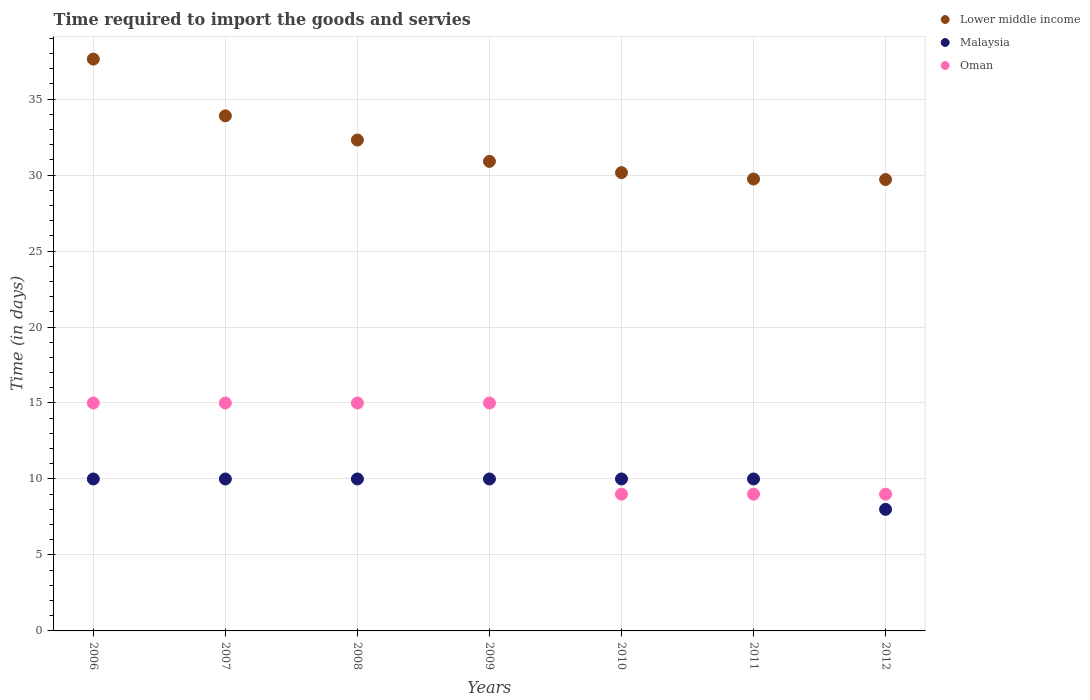How many different coloured dotlines are there?
Ensure brevity in your answer.  3. Is the number of dotlines equal to the number of legend labels?
Your answer should be very brief. Yes. What is the number of days required to import the goods and services in Malaysia in 2006?
Your answer should be very brief. 10. Across all years, what is the maximum number of days required to import the goods and services in Malaysia?
Make the answer very short. 10. Across all years, what is the minimum number of days required to import the goods and services in Oman?
Offer a terse response. 9. In which year was the number of days required to import the goods and services in Lower middle income maximum?
Your answer should be very brief. 2006. What is the total number of days required to import the goods and services in Malaysia in the graph?
Your response must be concise. 68. What is the difference between the number of days required to import the goods and services in Oman in 2009 and the number of days required to import the goods and services in Lower middle income in 2008?
Offer a terse response. -17.31. What is the average number of days required to import the goods and services in Oman per year?
Your response must be concise. 12.43. In the year 2006, what is the difference between the number of days required to import the goods and services in Lower middle income and number of days required to import the goods and services in Oman?
Make the answer very short. 22.63. In how many years, is the number of days required to import the goods and services in Oman greater than 9 days?
Keep it short and to the point. 4. What is the ratio of the number of days required to import the goods and services in Oman in 2006 to that in 2011?
Provide a short and direct response. 1.67. Is the number of days required to import the goods and services in Malaysia in 2008 less than that in 2010?
Give a very brief answer. No. What is the difference between the highest and the lowest number of days required to import the goods and services in Malaysia?
Your answer should be very brief. 2. Is the sum of the number of days required to import the goods and services in Lower middle income in 2011 and 2012 greater than the maximum number of days required to import the goods and services in Oman across all years?
Your answer should be compact. Yes. Is it the case that in every year, the sum of the number of days required to import the goods and services in Lower middle income and number of days required to import the goods and services in Oman  is greater than the number of days required to import the goods and services in Malaysia?
Your response must be concise. Yes. Does the number of days required to import the goods and services in Malaysia monotonically increase over the years?
Offer a very short reply. No. How many dotlines are there?
Your answer should be compact. 3. Are the values on the major ticks of Y-axis written in scientific E-notation?
Provide a succinct answer. No. Does the graph contain grids?
Provide a succinct answer. Yes. Where does the legend appear in the graph?
Your answer should be compact. Top right. How many legend labels are there?
Offer a very short reply. 3. What is the title of the graph?
Offer a terse response. Time required to import the goods and servies. Does "Benin" appear as one of the legend labels in the graph?
Give a very brief answer. No. What is the label or title of the X-axis?
Offer a terse response. Years. What is the label or title of the Y-axis?
Your answer should be very brief. Time (in days). What is the Time (in days) in Lower middle income in 2006?
Make the answer very short. 37.63. What is the Time (in days) of Oman in 2006?
Offer a terse response. 15. What is the Time (in days) in Lower middle income in 2007?
Ensure brevity in your answer.  33.9. What is the Time (in days) in Malaysia in 2007?
Make the answer very short. 10. What is the Time (in days) in Lower middle income in 2008?
Make the answer very short. 32.31. What is the Time (in days) of Lower middle income in 2009?
Give a very brief answer. 30.9. What is the Time (in days) of Oman in 2009?
Your answer should be very brief. 15. What is the Time (in days) of Lower middle income in 2010?
Give a very brief answer. 30.16. What is the Time (in days) in Malaysia in 2010?
Your answer should be very brief. 10. What is the Time (in days) in Oman in 2010?
Provide a short and direct response. 9. What is the Time (in days) in Lower middle income in 2011?
Make the answer very short. 29.74. What is the Time (in days) in Malaysia in 2011?
Offer a terse response. 10. What is the Time (in days) of Lower middle income in 2012?
Your response must be concise. 29.71. What is the Time (in days) of Malaysia in 2012?
Make the answer very short. 8. What is the Time (in days) in Oman in 2012?
Provide a short and direct response. 9. Across all years, what is the maximum Time (in days) in Lower middle income?
Provide a short and direct response. 37.63. Across all years, what is the maximum Time (in days) in Malaysia?
Your response must be concise. 10. Across all years, what is the maximum Time (in days) of Oman?
Your answer should be compact. 15. Across all years, what is the minimum Time (in days) of Lower middle income?
Offer a terse response. 29.71. Across all years, what is the minimum Time (in days) in Oman?
Keep it short and to the point. 9. What is the total Time (in days) in Lower middle income in the graph?
Give a very brief answer. 224.34. What is the total Time (in days) in Oman in the graph?
Provide a short and direct response. 87. What is the difference between the Time (in days) of Lower middle income in 2006 and that in 2007?
Keep it short and to the point. 3.73. What is the difference between the Time (in days) of Lower middle income in 2006 and that in 2008?
Offer a terse response. 5.33. What is the difference between the Time (in days) of Oman in 2006 and that in 2008?
Ensure brevity in your answer.  0. What is the difference between the Time (in days) of Lower middle income in 2006 and that in 2009?
Your answer should be compact. 6.73. What is the difference between the Time (in days) of Malaysia in 2006 and that in 2009?
Your answer should be compact. 0. What is the difference between the Time (in days) of Lower middle income in 2006 and that in 2010?
Provide a succinct answer. 7.47. What is the difference between the Time (in days) of Malaysia in 2006 and that in 2010?
Your answer should be very brief. 0. What is the difference between the Time (in days) in Lower middle income in 2006 and that in 2011?
Provide a succinct answer. 7.89. What is the difference between the Time (in days) in Malaysia in 2006 and that in 2011?
Ensure brevity in your answer.  0. What is the difference between the Time (in days) of Oman in 2006 and that in 2011?
Your answer should be very brief. 6. What is the difference between the Time (in days) in Lower middle income in 2006 and that in 2012?
Provide a succinct answer. 7.93. What is the difference between the Time (in days) of Oman in 2006 and that in 2012?
Make the answer very short. 6. What is the difference between the Time (in days) in Lower middle income in 2007 and that in 2008?
Provide a short and direct response. 1.59. What is the difference between the Time (in days) of Malaysia in 2007 and that in 2008?
Offer a very short reply. 0. What is the difference between the Time (in days) of Oman in 2007 and that in 2008?
Your response must be concise. 0. What is the difference between the Time (in days) of Lower middle income in 2007 and that in 2009?
Your answer should be very brief. 3. What is the difference between the Time (in days) of Malaysia in 2007 and that in 2009?
Offer a very short reply. 0. What is the difference between the Time (in days) of Oman in 2007 and that in 2009?
Your response must be concise. 0. What is the difference between the Time (in days) in Lower middle income in 2007 and that in 2010?
Provide a succinct answer. 3.74. What is the difference between the Time (in days) in Malaysia in 2007 and that in 2010?
Provide a succinct answer. 0. What is the difference between the Time (in days) in Lower middle income in 2007 and that in 2011?
Provide a short and direct response. 4.16. What is the difference between the Time (in days) of Oman in 2007 and that in 2011?
Keep it short and to the point. 6. What is the difference between the Time (in days) in Lower middle income in 2007 and that in 2012?
Your answer should be very brief. 4.19. What is the difference between the Time (in days) in Oman in 2007 and that in 2012?
Your answer should be very brief. 6. What is the difference between the Time (in days) of Lower middle income in 2008 and that in 2009?
Ensure brevity in your answer.  1.41. What is the difference between the Time (in days) in Malaysia in 2008 and that in 2009?
Keep it short and to the point. 0. What is the difference between the Time (in days) of Lower middle income in 2008 and that in 2010?
Your response must be concise. 2.15. What is the difference between the Time (in days) in Malaysia in 2008 and that in 2010?
Your answer should be very brief. 0. What is the difference between the Time (in days) of Lower middle income in 2008 and that in 2011?
Provide a short and direct response. 2.57. What is the difference between the Time (in days) in Lower middle income in 2008 and that in 2012?
Your response must be concise. 2.6. What is the difference between the Time (in days) of Malaysia in 2008 and that in 2012?
Your answer should be very brief. 2. What is the difference between the Time (in days) in Oman in 2008 and that in 2012?
Offer a very short reply. 6. What is the difference between the Time (in days) in Lower middle income in 2009 and that in 2010?
Make the answer very short. 0.74. What is the difference between the Time (in days) in Malaysia in 2009 and that in 2010?
Give a very brief answer. 0. What is the difference between the Time (in days) of Lower middle income in 2009 and that in 2011?
Your answer should be compact. 1.16. What is the difference between the Time (in days) in Malaysia in 2009 and that in 2011?
Offer a terse response. 0. What is the difference between the Time (in days) in Lower middle income in 2009 and that in 2012?
Give a very brief answer. 1.19. What is the difference between the Time (in days) in Oman in 2009 and that in 2012?
Offer a very short reply. 6. What is the difference between the Time (in days) of Lower middle income in 2010 and that in 2011?
Your answer should be very brief. 0.42. What is the difference between the Time (in days) in Oman in 2010 and that in 2011?
Your answer should be very brief. 0. What is the difference between the Time (in days) in Lower middle income in 2010 and that in 2012?
Your response must be concise. 0.45. What is the difference between the Time (in days) of Malaysia in 2010 and that in 2012?
Provide a succinct answer. 2. What is the difference between the Time (in days) in Lower middle income in 2011 and that in 2012?
Ensure brevity in your answer.  0.03. What is the difference between the Time (in days) of Malaysia in 2011 and that in 2012?
Your response must be concise. 2. What is the difference between the Time (in days) in Oman in 2011 and that in 2012?
Your response must be concise. 0. What is the difference between the Time (in days) of Lower middle income in 2006 and the Time (in days) of Malaysia in 2007?
Make the answer very short. 27.63. What is the difference between the Time (in days) in Lower middle income in 2006 and the Time (in days) in Oman in 2007?
Provide a succinct answer. 22.63. What is the difference between the Time (in days) in Malaysia in 2006 and the Time (in days) in Oman in 2007?
Your answer should be very brief. -5. What is the difference between the Time (in days) of Lower middle income in 2006 and the Time (in days) of Malaysia in 2008?
Provide a short and direct response. 27.63. What is the difference between the Time (in days) in Lower middle income in 2006 and the Time (in days) in Oman in 2008?
Provide a succinct answer. 22.63. What is the difference between the Time (in days) of Lower middle income in 2006 and the Time (in days) of Malaysia in 2009?
Offer a very short reply. 27.63. What is the difference between the Time (in days) in Lower middle income in 2006 and the Time (in days) in Oman in 2009?
Give a very brief answer. 22.63. What is the difference between the Time (in days) in Malaysia in 2006 and the Time (in days) in Oman in 2009?
Provide a short and direct response. -5. What is the difference between the Time (in days) of Lower middle income in 2006 and the Time (in days) of Malaysia in 2010?
Give a very brief answer. 27.63. What is the difference between the Time (in days) in Lower middle income in 2006 and the Time (in days) in Oman in 2010?
Your answer should be compact. 28.63. What is the difference between the Time (in days) of Lower middle income in 2006 and the Time (in days) of Malaysia in 2011?
Ensure brevity in your answer.  27.63. What is the difference between the Time (in days) of Lower middle income in 2006 and the Time (in days) of Oman in 2011?
Provide a short and direct response. 28.63. What is the difference between the Time (in days) in Lower middle income in 2006 and the Time (in days) in Malaysia in 2012?
Your answer should be very brief. 29.63. What is the difference between the Time (in days) in Lower middle income in 2006 and the Time (in days) in Oman in 2012?
Your response must be concise. 28.63. What is the difference between the Time (in days) of Lower middle income in 2007 and the Time (in days) of Malaysia in 2008?
Ensure brevity in your answer.  23.9. What is the difference between the Time (in days) of Lower middle income in 2007 and the Time (in days) of Oman in 2008?
Your response must be concise. 18.9. What is the difference between the Time (in days) in Malaysia in 2007 and the Time (in days) in Oman in 2008?
Your answer should be very brief. -5. What is the difference between the Time (in days) in Lower middle income in 2007 and the Time (in days) in Malaysia in 2009?
Keep it short and to the point. 23.9. What is the difference between the Time (in days) of Lower middle income in 2007 and the Time (in days) of Oman in 2009?
Your response must be concise. 18.9. What is the difference between the Time (in days) in Lower middle income in 2007 and the Time (in days) in Malaysia in 2010?
Provide a succinct answer. 23.9. What is the difference between the Time (in days) in Lower middle income in 2007 and the Time (in days) in Oman in 2010?
Make the answer very short. 24.9. What is the difference between the Time (in days) in Lower middle income in 2007 and the Time (in days) in Malaysia in 2011?
Provide a short and direct response. 23.9. What is the difference between the Time (in days) of Lower middle income in 2007 and the Time (in days) of Oman in 2011?
Your answer should be compact. 24.9. What is the difference between the Time (in days) of Lower middle income in 2007 and the Time (in days) of Malaysia in 2012?
Provide a short and direct response. 25.9. What is the difference between the Time (in days) in Lower middle income in 2007 and the Time (in days) in Oman in 2012?
Your answer should be compact. 24.9. What is the difference between the Time (in days) of Malaysia in 2007 and the Time (in days) of Oman in 2012?
Offer a very short reply. 1. What is the difference between the Time (in days) of Lower middle income in 2008 and the Time (in days) of Malaysia in 2009?
Your answer should be very brief. 22.31. What is the difference between the Time (in days) of Lower middle income in 2008 and the Time (in days) of Oman in 2009?
Provide a succinct answer. 17.31. What is the difference between the Time (in days) in Lower middle income in 2008 and the Time (in days) in Malaysia in 2010?
Your answer should be compact. 22.31. What is the difference between the Time (in days) of Lower middle income in 2008 and the Time (in days) of Oman in 2010?
Offer a very short reply. 23.31. What is the difference between the Time (in days) of Lower middle income in 2008 and the Time (in days) of Malaysia in 2011?
Give a very brief answer. 22.31. What is the difference between the Time (in days) in Lower middle income in 2008 and the Time (in days) in Oman in 2011?
Provide a short and direct response. 23.31. What is the difference between the Time (in days) in Lower middle income in 2008 and the Time (in days) in Malaysia in 2012?
Make the answer very short. 24.31. What is the difference between the Time (in days) of Lower middle income in 2008 and the Time (in days) of Oman in 2012?
Provide a short and direct response. 23.31. What is the difference between the Time (in days) of Malaysia in 2008 and the Time (in days) of Oman in 2012?
Make the answer very short. 1. What is the difference between the Time (in days) of Lower middle income in 2009 and the Time (in days) of Malaysia in 2010?
Make the answer very short. 20.9. What is the difference between the Time (in days) in Lower middle income in 2009 and the Time (in days) in Oman in 2010?
Offer a terse response. 21.9. What is the difference between the Time (in days) in Malaysia in 2009 and the Time (in days) in Oman in 2010?
Keep it short and to the point. 1. What is the difference between the Time (in days) of Lower middle income in 2009 and the Time (in days) of Malaysia in 2011?
Offer a terse response. 20.9. What is the difference between the Time (in days) in Lower middle income in 2009 and the Time (in days) in Oman in 2011?
Keep it short and to the point. 21.9. What is the difference between the Time (in days) in Malaysia in 2009 and the Time (in days) in Oman in 2011?
Your answer should be compact. 1. What is the difference between the Time (in days) in Lower middle income in 2009 and the Time (in days) in Malaysia in 2012?
Your answer should be very brief. 22.9. What is the difference between the Time (in days) of Lower middle income in 2009 and the Time (in days) of Oman in 2012?
Your answer should be compact. 21.9. What is the difference between the Time (in days) of Lower middle income in 2010 and the Time (in days) of Malaysia in 2011?
Provide a succinct answer. 20.16. What is the difference between the Time (in days) of Lower middle income in 2010 and the Time (in days) of Oman in 2011?
Your answer should be very brief. 21.16. What is the difference between the Time (in days) in Malaysia in 2010 and the Time (in days) in Oman in 2011?
Make the answer very short. 1. What is the difference between the Time (in days) of Lower middle income in 2010 and the Time (in days) of Malaysia in 2012?
Offer a very short reply. 22.16. What is the difference between the Time (in days) in Lower middle income in 2010 and the Time (in days) in Oman in 2012?
Your response must be concise. 21.16. What is the difference between the Time (in days) in Malaysia in 2010 and the Time (in days) in Oman in 2012?
Your answer should be very brief. 1. What is the difference between the Time (in days) in Lower middle income in 2011 and the Time (in days) in Malaysia in 2012?
Your answer should be very brief. 21.74. What is the difference between the Time (in days) of Lower middle income in 2011 and the Time (in days) of Oman in 2012?
Your answer should be compact. 20.74. What is the difference between the Time (in days) of Malaysia in 2011 and the Time (in days) of Oman in 2012?
Give a very brief answer. 1. What is the average Time (in days) in Lower middle income per year?
Offer a terse response. 32.05. What is the average Time (in days) of Malaysia per year?
Offer a terse response. 9.71. What is the average Time (in days) of Oman per year?
Provide a succinct answer. 12.43. In the year 2006, what is the difference between the Time (in days) in Lower middle income and Time (in days) in Malaysia?
Provide a succinct answer. 27.63. In the year 2006, what is the difference between the Time (in days) in Lower middle income and Time (in days) in Oman?
Provide a short and direct response. 22.63. In the year 2006, what is the difference between the Time (in days) of Malaysia and Time (in days) of Oman?
Your response must be concise. -5. In the year 2007, what is the difference between the Time (in days) of Lower middle income and Time (in days) of Malaysia?
Offer a terse response. 23.9. In the year 2007, what is the difference between the Time (in days) of Lower middle income and Time (in days) of Oman?
Keep it short and to the point. 18.9. In the year 2007, what is the difference between the Time (in days) of Malaysia and Time (in days) of Oman?
Give a very brief answer. -5. In the year 2008, what is the difference between the Time (in days) in Lower middle income and Time (in days) in Malaysia?
Offer a terse response. 22.31. In the year 2008, what is the difference between the Time (in days) in Lower middle income and Time (in days) in Oman?
Provide a succinct answer. 17.31. In the year 2009, what is the difference between the Time (in days) in Lower middle income and Time (in days) in Malaysia?
Give a very brief answer. 20.9. In the year 2010, what is the difference between the Time (in days) in Lower middle income and Time (in days) in Malaysia?
Keep it short and to the point. 20.16. In the year 2010, what is the difference between the Time (in days) in Lower middle income and Time (in days) in Oman?
Your response must be concise. 21.16. In the year 2011, what is the difference between the Time (in days) of Lower middle income and Time (in days) of Malaysia?
Make the answer very short. 19.74. In the year 2011, what is the difference between the Time (in days) of Lower middle income and Time (in days) of Oman?
Offer a terse response. 20.74. In the year 2012, what is the difference between the Time (in days) in Lower middle income and Time (in days) in Malaysia?
Your answer should be very brief. 21.71. In the year 2012, what is the difference between the Time (in days) in Lower middle income and Time (in days) in Oman?
Ensure brevity in your answer.  20.71. What is the ratio of the Time (in days) of Lower middle income in 2006 to that in 2007?
Offer a terse response. 1.11. What is the ratio of the Time (in days) in Malaysia in 2006 to that in 2007?
Ensure brevity in your answer.  1. What is the ratio of the Time (in days) in Oman in 2006 to that in 2007?
Make the answer very short. 1. What is the ratio of the Time (in days) in Lower middle income in 2006 to that in 2008?
Offer a terse response. 1.16. What is the ratio of the Time (in days) of Oman in 2006 to that in 2008?
Ensure brevity in your answer.  1. What is the ratio of the Time (in days) of Lower middle income in 2006 to that in 2009?
Your answer should be very brief. 1.22. What is the ratio of the Time (in days) in Malaysia in 2006 to that in 2009?
Keep it short and to the point. 1. What is the ratio of the Time (in days) of Oman in 2006 to that in 2009?
Your answer should be compact. 1. What is the ratio of the Time (in days) in Lower middle income in 2006 to that in 2010?
Make the answer very short. 1.25. What is the ratio of the Time (in days) in Malaysia in 2006 to that in 2010?
Provide a short and direct response. 1. What is the ratio of the Time (in days) in Lower middle income in 2006 to that in 2011?
Offer a very short reply. 1.27. What is the ratio of the Time (in days) of Malaysia in 2006 to that in 2011?
Your answer should be compact. 1. What is the ratio of the Time (in days) in Oman in 2006 to that in 2011?
Your answer should be compact. 1.67. What is the ratio of the Time (in days) of Lower middle income in 2006 to that in 2012?
Make the answer very short. 1.27. What is the ratio of the Time (in days) of Lower middle income in 2007 to that in 2008?
Give a very brief answer. 1.05. What is the ratio of the Time (in days) in Lower middle income in 2007 to that in 2009?
Offer a terse response. 1.1. What is the ratio of the Time (in days) in Malaysia in 2007 to that in 2009?
Your answer should be compact. 1. What is the ratio of the Time (in days) of Lower middle income in 2007 to that in 2010?
Provide a succinct answer. 1.12. What is the ratio of the Time (in days) of Lower middle income in 2007 to that in 2011?
Provide a short and direct response. 1.14. What is the ratio of the Time (in days) of Lower middle income in 2007 to that in 2012?
Provide a short and direct response. 1.14. What is the ratio of the Time (in days) in Malaysia in 2007 to that in 2012?
Make the answer very short. 1.25. What is the ratio of the Time (in days) in Oman in 2007 to that in 2012?
Your answer should be compact. 1.67. What is the ratio of the Time (in days) in Lower middle income in 2008 to that in 2009?
Provide a short and direct response. 1.05. What is the ratio of the Time (in days) of Malaysia in 2008 to that in 2009?
Your response must be concise. 1. What is the ratio of the Time (in days) of Lower middle income in 2008 to that in 2010?
Offer a very short reply. 1.07. What is the ratio of the Time (in days) of Lower middle income in 2008 to that in 2011?
Ensure brevity in your answer.  1.09. What is the ratio of the Time (in days) of Oman in 2008 to that in 2011?
Keep it short and to the point. 1.67. What is the ratio of the Time (in days) in Lower middle income in 2008 to that in 2012?
Give a very brief answer. 1.09. What is the ratio of the Time (in days) of Lower middle income in 2009 to that in 2010?
Your answer should be compact. 1.02. What is the ratio of the Time (in days) in Oman in 2009 to that in 2010?
Provide a short and direct response. 1.67. What is the ratio of the Time (in days) of Lower middle income in 2009 to that in 2011?
Offer a terse response. 1.04. What is the ratio of the Time (in days) in Oman in 2009 to that in 2011?
Offer a terse response. 1.67. What is the ratio of the Time (in days) in Lower middle income in 2009 to that in 2012?
Your answer should be compact. 1.04. What is the ratio of the Time (in days) in Malaysia in 2009 to that in 2012?
Offer a very short reply. 1.25. What is the ratio of the Time (in days) in Lower middle income in 2010 to that in 2011?
Give a very brief answer. 1.01. What is the ratio of the Time (in days) of Oman in 2010 to that in 2011?
Provide a succinct answer. 1. What is the ratio of the Time (in days) in Lower middle income in 2010 to that in 2012?
Offer a terse response. 1.02. What is the ratio of the Time (in days) in Malaysia in 2010 to that in 2012?
Provide a succinct answer. 1.25. What is the ratio of the Time (in days) of Oman in 2010 to that in 2012?
Your response must be concise. 1. What is the ratio of the Time (in days) of Lower middle income in 2011 to that in 2012?
Offer a very short reply. 1. What is the difference between the highest and the second highest Time (in days) of Lower middle income?
Your answer should be very brief. 3.73. What is the difference between the highest and the lowest Time (in days) of Lower middle income?
Make the answer very short. 7.93. What is the difference between the highest and the lowest Time (in days) of Malaysia?
Your answer should be compact. 2. What is the difference between the highest and the lowest Time (in days) of Oman?
Your answer should be very brief. 6. 